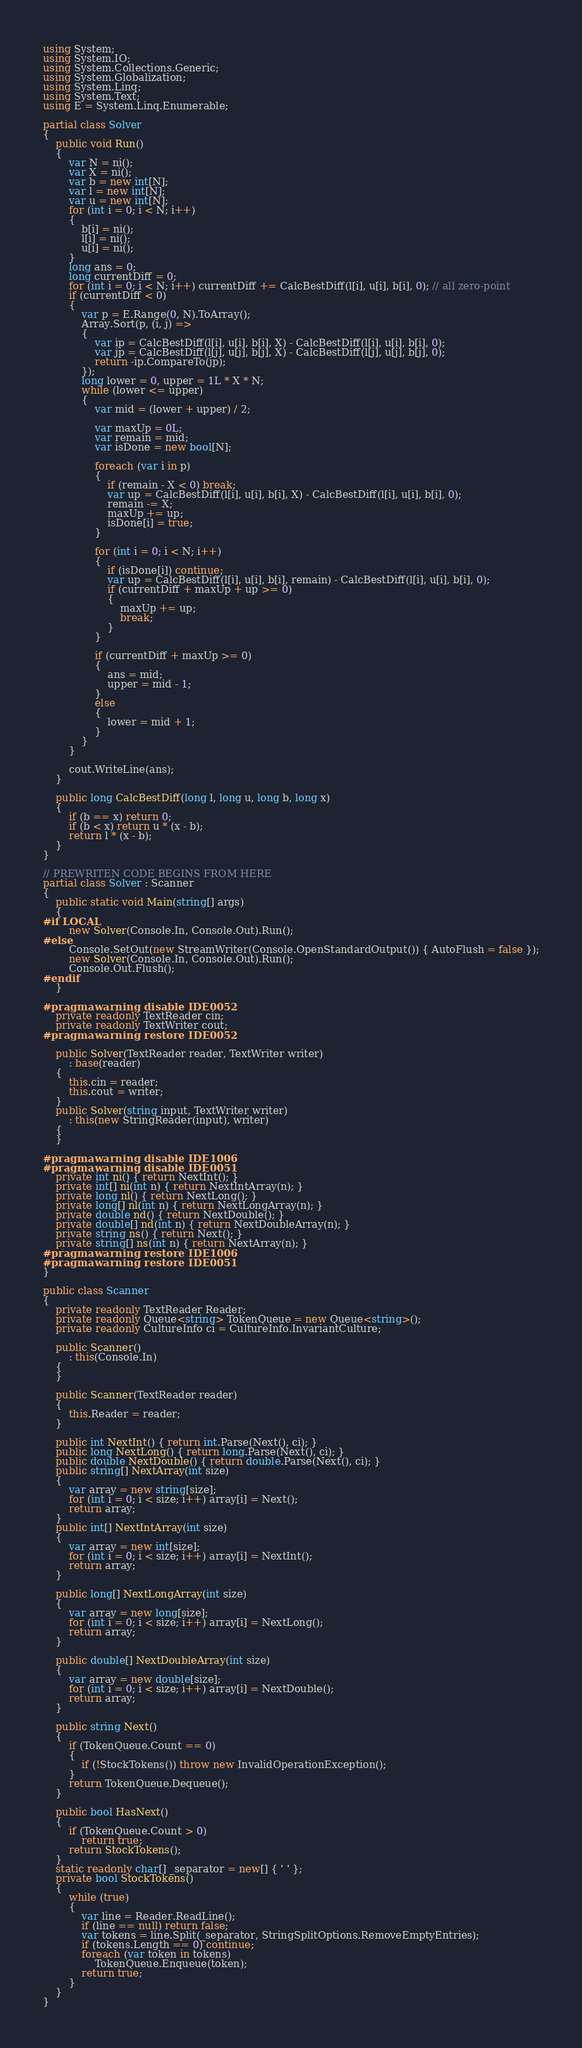Convert code to text. <code><loc_0><loc_0><loc_500><loc_500><_C#_>using System;
using System.IO;
using System.Collections.Generic;
using System.Globalization;
using System.Linq;
using System.Text;
using E = System.Linq.Enumerable;

partial class Solver
{
    public void Run()
    {
        var N = ni();
        var X = ni();
        var b = new int[N];
        var l = new int[N];
        var u = new int[N];
        for (int i = 0; i < N; i++)
        {
            b[i] = ni();
            l[i] = ni();
            u[i] = ni();
        }
        long ans = 0;
        long currentDiff = 0;
        for (int i = 0; i < N; i++) currentDiff += CalcBestDiff(l[i], u[i], b[i], 0); // all zero-point
        if (currentDiff < 0)
        {
            var p = E.Range(0, N).ToArray();
            Array.Sort(p, (i, j) =>
            {
                var ip = CalcBestDiff(l[i], u[i], b[i], X) - CalcBestDiff(l[i], u[i], b[i], 0);
                var jp = CalcBestDiff(l[j], u[j], b[j], X) - CalcBestDiff(l[j], u[j], b[j], 0);
                return -ip.CompareTo(jp);
            });
            long lower = 0, upper = 1L * X * N;
            while (lower <= upper)
            {
                var mid = (lower + upper) / 2;

                var maxUp = 0L;
                var remain = mid;
                var isDone = new bool[N];

                foreach (var i in p)
                {
                    if (remain - X < 0) break;
                    var up = CalcBestDiff(l[i], u[i], b[i], X) - CalcBestDiff(l[i], u[i], b[i], 0);
                    remain -= X;
                    maxUp += up;
                    isDone[i] = true;
                }

                for (int i = 0; i < N; i++)
                {
                    if (isDone[i]) continue;
                    var up = CalcBestDiff(l[i], u[i], b[i], remain) - CalcBestDiff(l[i], u[i], b[i], 0);
                    if (currentDiff + maxUp + up >= 0)
                    {
                        maxUp += up;
                        break;
                    }
                }

                if (currentDiff + maxUp >= 0)
                {
                    ans = mid;
                    upper = mid - 1;
                }
                else
                {
                    lower = mid + 1;
                }
            }
        }

        cout.WriteLine(ans);
    }

    public long CalcBestDiff(long l, long u, long b, long x)
    {
        if (b == x) return 0;
        if (b < x) return u * (x - b);
        return l * (x - b);
    }
}

// PREWRITEN CODE BEGINS FROM HERE
partial class Solver : Scanner
{
    public static void Main(string[] args)
    {
#if LOCAL
        new Solver(Console.In, Console.Out).Run();
#else
        Console.SetOut(new StreamWriter(Console.OpenStandardOutput()) { AutoFlush = false });
        new Solver(Console.In, Console.Out).Run();
        Console.Out.Flush();
#endif
    }

#pragma warning disable IDE0052
    private readonly TextReader cin;
    private readonly TextWriter cout;
#pragma warning restore IDE0052

    public Solver(TextReader reader, TextWriter writer)
        : base(reader)
    {
        this.cin = reader;
        this.cout = writer;
    }
    public Solver(string input, TextWriter writer)
        : this(new StringReader(input), writer)
    {
    }

#pragma warning disable IDE1006
#pragma warning disable IDE0051
    private int ni() { return NextInt(); }
    private int[] ni(int n) { return NextIntArray(n); }
    private long nl() { return NextLong(); }
    private long[] nl(int n) { return NextLongArray(n); }
    private double nd() { return NextDouble(); }
    private double[] nd(int n) { return NextDoubleArray(n); }
    private string ns() { return Next(); }
    private string[] ns(int n) { return NextArray(n); }
#pragma warning restore IDE1006
#pragma warning restore IDE0051
}

public class Scanner
{
    private readonly TextReader Reader;
    private readonly Queue<string> TokenQueue = new Queue<string>();
    private readonly CultureInfo ci = CultureInfo.InvariantCulture;

    public Scanner()
        : this(Console.In)
    {
    }

    public Scanner(TextReader reader)
    {
        this.Reader = reader;
    }

    public int NextInt() { return int.Parse(Next(), ci); }
    public long NextLong() { return long.Parse(Next(), ci); }
    public double NextDouble() { return double.Parse(Next(), ci); }
    public string[] NextArray(int size)
    {
        var array = new string[size];
        for (int i = 0; i < size; i++) array[i] = Next();
        return array;
    }
    public int[] NextIntArray(int size)
    {
        var array = new int[size];
        for (int i = 0; i < size; i++) array[i] = NextInt();
        return array;
    }

    public long[] NextLongArray(int size)
    {
        var array = new long[size];
        for (int i = 0; i < size; i++) array[i] = NextLong();
        return array;
    }

    public double[] NextDoubleArray(int size)
    {
        var array = new double[size];
        for (int i = 0; i < size; i++) array[i] = NextDouble();
        return array;
    }

    public string Next()
    {
        if (TokenQueue.Count == 0)
        {
            if (!StockTokens()) throw new InvalidOperationException();
        }
        return TokenQueue.Dequeue();
    }

    public bool HasNext()
    {
        if (TokenQueue.Count > 0)
            return true;
        return StockTokens();
    }
    static readonly char[] _separator = new[] { ' ' };
    private bool StockTokens()
    {
        while (true)
        {
            var line = Reader.ReadLine();
            if (line == null) return false;
            var tokens = line.Split(_separator, StringSplitOptions.RemoveEmptyEntries);
            if (tokens.Length == 0) continue;
            foreach (var token in tokens)
                TokenQueue.Enqueue(token);
            return true;
        }
    }
}
</code> 